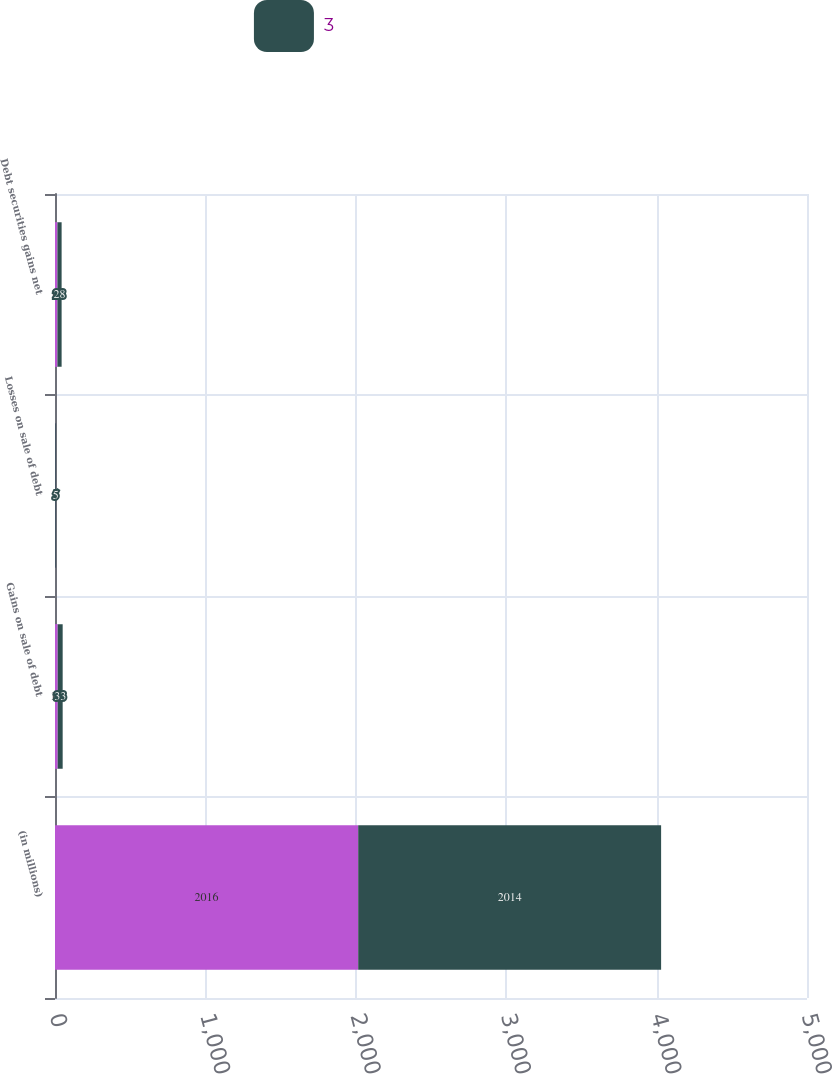Convert chart to OTSL. <chart><loc_0><loc_0><loc_500><loc_500><stacked_bar_chart><ecel><fcel>(in millions)<fcel>Gains on sale of debt<fcel>Losses on sale of debt<fcel>Debt securities gains net<nl><fcel>nan<fcel>2016<fcel>18<fcel>2<fcel>16<nl><fcel>3<fcel>2014<fcel>33<fcel>5<fcel>28<nl></chart> 